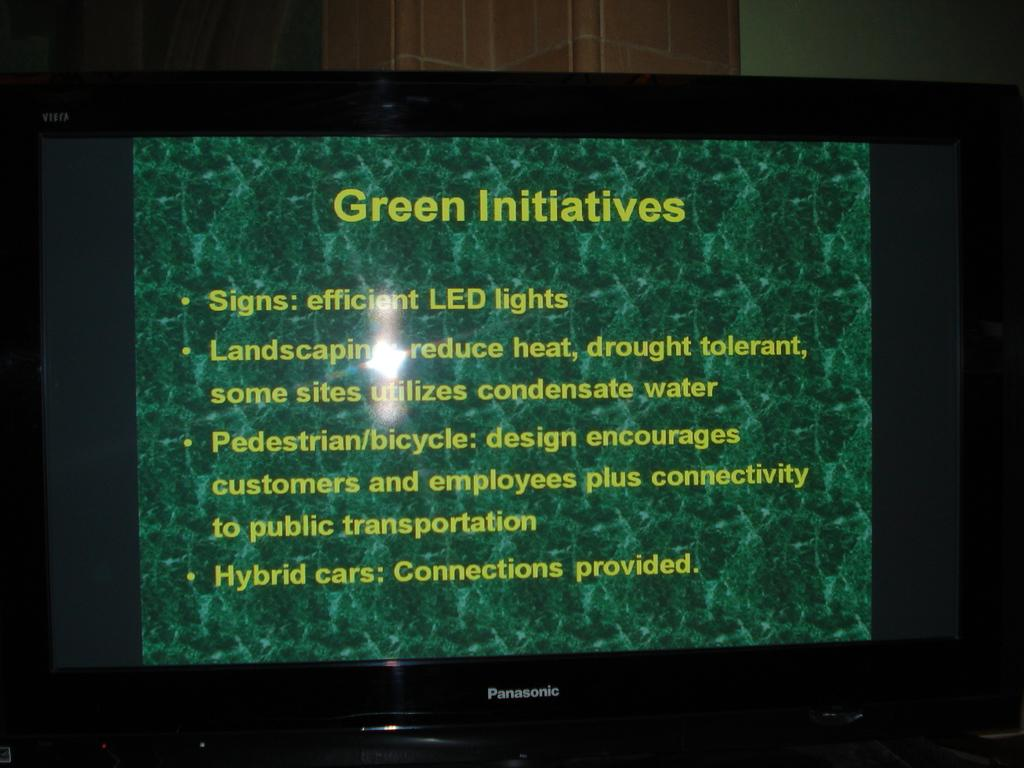Provide a one-sentence caption for the provided image. A Panasonic screen shows a slide that says Green Initiatives. 